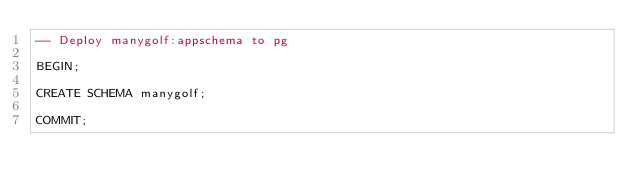Convert code to text. <code><loc_0><loc_0><loc_500><loc_500><_SQL_>-- Deploy manygolf:appschema to pg

BEGIN;

CREATE SCHEMA manygolf;

COMMIT;
</code> 